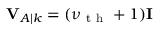<formula> <loc_0><loc_0><loc_500><loc_500>V _ { A | k } = ( \nu _ { t h } + 1 ) I</formula> 